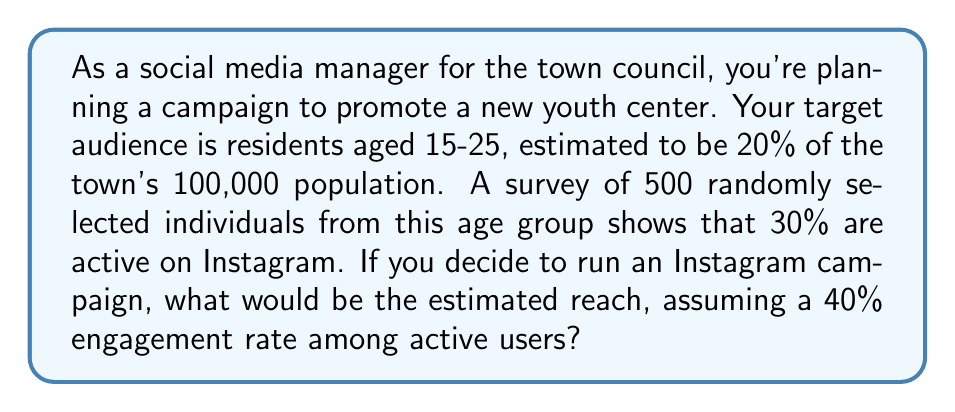Can you solve this math problem? Let's break this down step-by-step:

1. Calculate the target population size:
   $$ \text{Target population} = 20\% \times 100,000 = 20,000 $$

2. Estimate the number of Instagram users in the target population:
   From the survey, 30% of the 500 sampled individuals are active on Instagram.
   We can apply this percentage to the entire target population:
   $$ \text{Instagram users} = 30\% \times 20,000 = 6,000 $$

3. Calculate the estimated reach with a 40% engagement rate:
   $$ \text{Estimated reach} = 40\% \times 6,000 = 2,400 $$

Therefore, the estimated reach of the Instagram campaign would be 2,400 people from the target demographic.
Answer: 2,400 people 